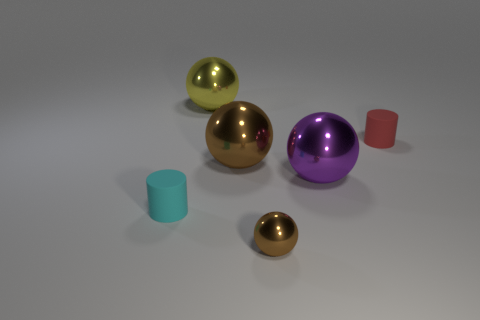Add 4 cylinders. How many objects exist? 10 Subtract all spheres. How many objects are left? 2 Subtract 0 gray blocks. How many objects are left? 6 Subtract all small cyan things. Subtract all red rubber cylinders. How many objects are left? 4 Add 5 small cylinders. How many small cylinders are left? 7 Add 3 red things. How many red things exist? 4 